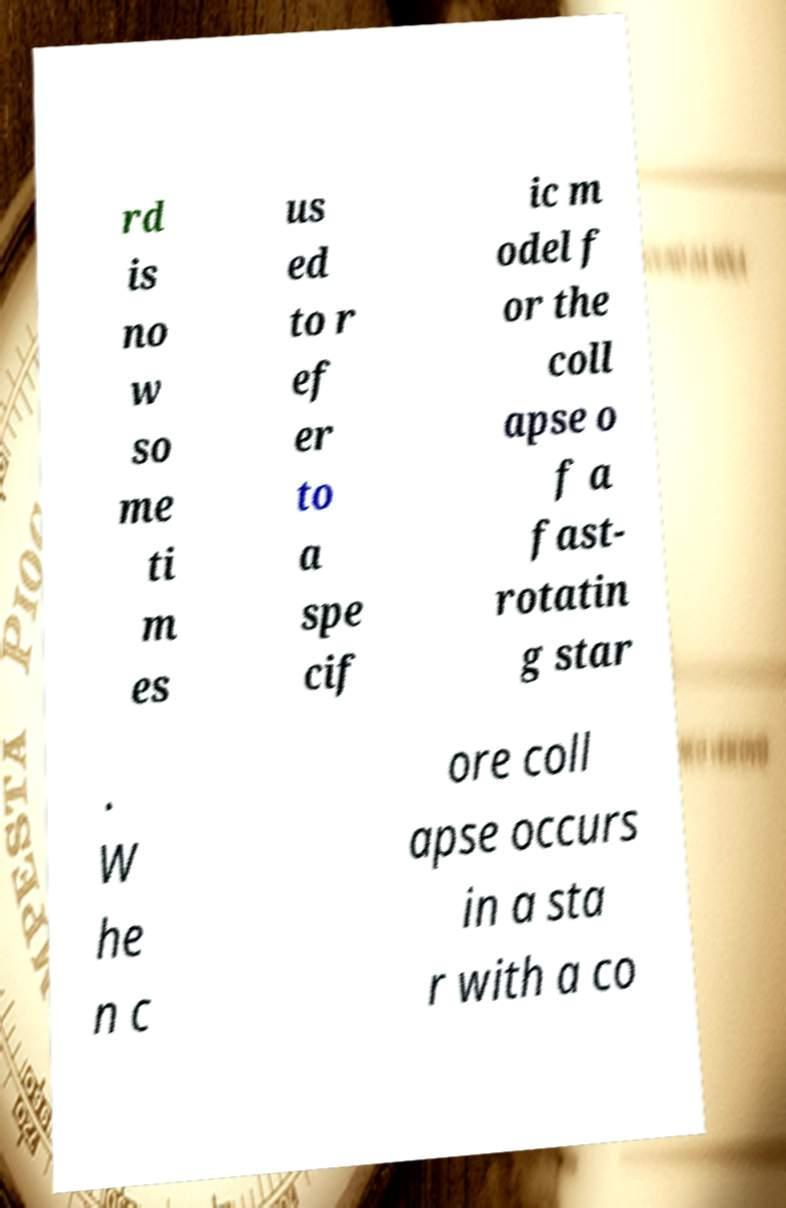Could you assist in decoding the text presented in this image and type it out clearly? rd is no w so me ti m es us ed to r ef er to a spe cif ic m odel f or the coll apse o f a fast- rotatin g star . W he n c ore coll apse occurs in a sta r with a co 